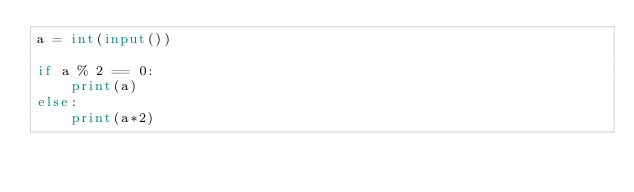Convert code to text. <code><loc_0><loc_0><loc_500><loc_500><_Python_>a = int(input())

if a % 2 == 0:
    print(a)
else:
    print(a*2)</code> 